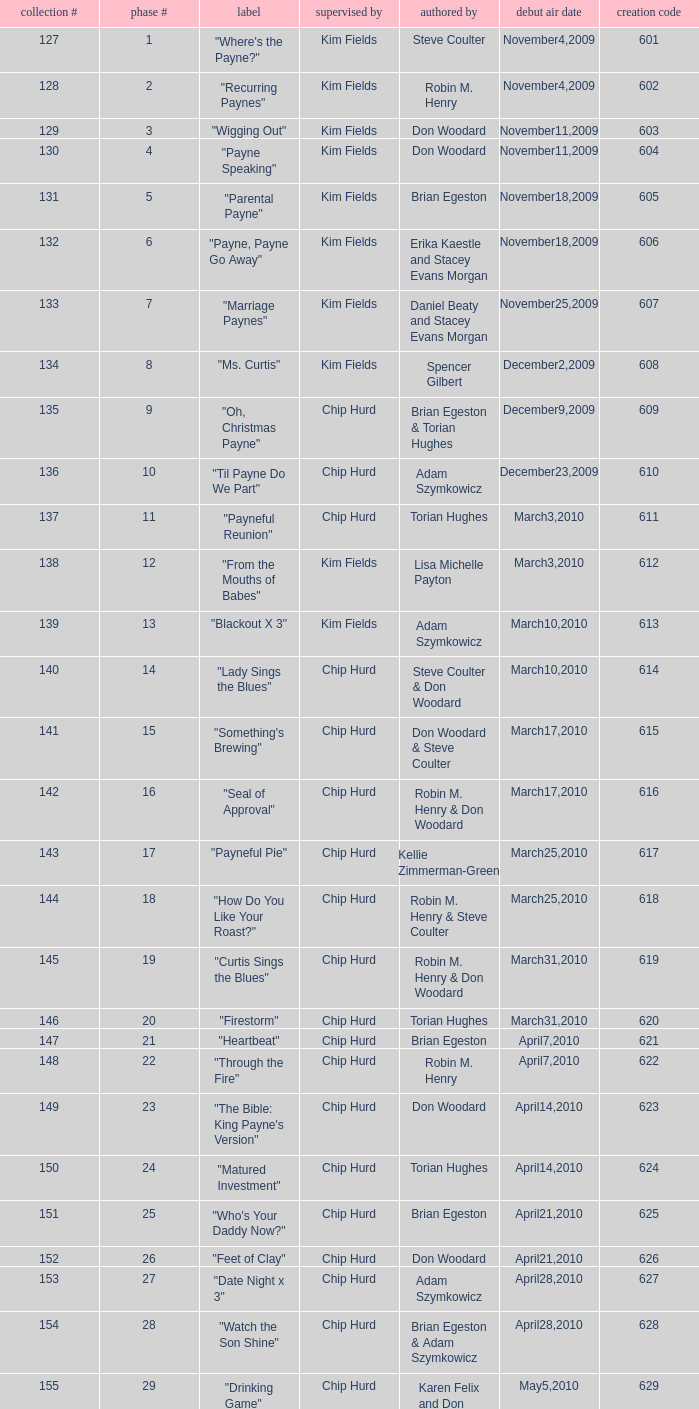What is the original air dates for the title "firestorm"? March31,2010. Give me the full table as a dictionary. {'header': ['collection #', 'phase #', 'label', 'supervised by', 'authored by', 'debut air date', 'creation code'], 'rows': [['127', '1', '"Where\'s the Payne?"', 'Kim Fields', 'Steve Coulter', 'November4,2009', '601'], ['128', '2', '"Recurring Paynes"', 'Kim Fields', 'Robin M. Henry', 'November4,2009', '602'], ['129', '3', '"Wigging Out"', 'Kim Fields', 'Don Woodard', 'November11,2009', '603'], ['130', '4', '"Payne Speaking"', 'Kim Fields', 'Don Woodard', 'November11,2009', '604'], ['131', '5', '"Parental Payne"', 'Kim Fields', 'Brian Egeston', 'November18,2009', '605'], ['132', '6', '"Payne, Payne Go Away"', 'Kim Fields', 'Erika Kaestle and Stacey Evans Morgan', 'November18,2009', '606'], ['133', '7', '"Marriage Paynes"', 'Kim Fields', 'Daniel Beaty and Stacey Evans Morgan', 'November25,2009', '607'], ['134', '8', '"Ms. Curtis"', 'Kim Fields', 'Spencer Gilbert', 'December2,2009', '608'], ['135', '9', '"Oh, Christmas Payne"', 'Chip Hurd', 'Brian Egeston & Torian Hughes', 'December9,2009', '609'], ['136', '10', '"Til Payne Do We Part"', 'Chip Hurd', 'Adam Szymkowicz', 'December23,2009', '610'], ['137', '11', '"Payneful Reunion"', 'Chip Hurd', 'Torian Hughes', 'March3,2010', '611'], ['138', '12', '"From the Mouths of Babes"', 'Kim Fields', 'Lisa Michelle Payton', 'March3,2010', '612'], ['139', '13', '"Blackout X 3"', 'Kim Fields', 'Adam Szymkowicz', 'March10,2010', '613'], ['140', '14', '"Lady Sings the Blues"', 'Chip Hurd', 'Steve Coulter & Don Woodard', 'March10,2010', '614'], ['141', '15', '"Something\'s Brewing"', 'Chip Hurd', 'Don Woodard & Steve Coulter', 'March17,2010', '615'], ['142', '16', '"Seal of Approval"', 'Chip Hurd', 'Robin M. Henry & Don Woodard', 'March17,2010', '616'], ['143', '17', '"Payneful Pie"', 'Chip Hurd', 'Kellie Zimmerman-Green', 'March25,2010', '617'], ['144', '18', '"How Do You Like Your Roast?"', 'Chip Hurd', 'Robin M. Henry & Steve Coulter', 'March25,2010', '618'], ['145', '19', '"Curtis Sings the Blues"', 'Chip Hurd', 'Robin M. Henry & Don Woodard', 'March31,2010', '619'], ['146', '20', '"Firestorm"', 'Chip Hurd', 'Torian Hughes', 'March31,2010', '620'], ['147', '21', '"Heartbeat"', 'Chip Hurd', 'Brian Egeston', 'April7,2010', '621'], ['148', '22', '"Through the Fire"', 'Chip Hurd', 'Robin M. Henry', 'April7,2010', '622'], ['149', '23', '"The Bible: King Payne\'s Version"', 'Chip Hurd', 'Don Woodard', 'April14,2010', '623'], ['150', '24', '"Matured Investment"', 'Chip Hurd', 'Torian Hughes', 'April14,2010', '624'], ['151', '25', '"Who\'s Your Daddy Now?"', 'Chip Hurd', 'Brian Egeston', 'April21,2010', '625'], ['152', '26', '"Feet of Clay"', 'Chip Hurd', 'Don Woodard', 'April21,2010', '626'], ['153', '27', '"Date Night x 3"', 'Chip Hurd', 'Adam Szymkowicz', 'April28,2010', '627'], ['154', '28', '"Watch the Son Shine"', 'Chip Hurd', 'Brian Egeston & Adam Szymkowicz', 'April28,2010', '628'], ['155', '29', '"Drinking Game"', 'Chip Hurd', 'Karen Felix and Don Woodard', 'May5,2010', '629'], ['156', '30', '"Who\'s On Top?"', 'Chip Hurd', 'Robin M. Henry & Torian Hughes', 'May5,2010', '630'], ['157', '31', '"Help, Help, Help"', 'Chip Hurd', 'Brian Egeston & Robin M. Henry', 'May12,2010', '631'], ['158', '32', '"Stinging Payne"', 'Chip Hurd', 'Don Woodard', 'May12,2010', '632'], ['159', '33', '"Worth Fighting For"', 'Chip Hurd', 'Torian Hughes', 'May19,2010', '633'], ['160', '34', '"Who\'s Your Nanny?"', 'Chip Hurd', 'Robin M. Henry & Adam Szymkowicz', 'May19,2010', '634'], ['161', '35', '"The Chef"', 'Chip Hurd', 'Anthony C. Hill', 'May26,2010', '635'], ['162', '36', '"My Fair Curtis"', 'Chip Hurd', 'Don Woodard', 'May26,2010', '636'], ['163', '37', '"Rest for the Weary"', 'Chip Hurd', 'Brian Egeston', 'June2,2010', '637'], ['164', '38', '"Thug Life"', 'Chip Hurd', 'Torian Hughes', 'June2,2010', '638'], ['165', '39', '"Rehabilitation"', 'Chip Hurd', 'Adam Szymkowicz', 'June9,2010', '639'], ['166', '40', '"A Payne In Need Is A Pain Indeed"', 'Chip Hurd', 'Don Woodard', 'June9,2010', '640'], ['167', '41', '"House Guest"', 'Chip Hurd', 'David A. Arnold', 'January5,2011', '641'], ['168', '42', '"Payne Showers"', 'Chip Hurd', 'Omega Mariaunnie Stewart and Torian Hughes', 'January5,2011', '642'], ['169', '43', '"Playing With Fire"', 'Chip Hurd', 'Carlos Portugal', 'January12,2011', '643'], ['170', '44', '"When the Payne\'s Away"', 'Chip Hurd', 'Kristin Topps and Don Woodard', 'January12,2011', '644'], ['171', '45', '"Beginnings"', 'Chip Hurd', 'Myra J.', 'January19,2011', '645']]} 